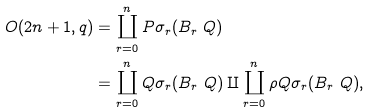Convert formula to latex. <formula><loc_0><loc_0><loc_500><loc_500>O ( 2 n + 1 , q ) & = \coprod _ { r = 0 } ^ { n } P \sigma _ { r } ( B _ { r } \ Q ) \\ & = \coprod _ { r = 0 } ^ { n } Q \sigma _ { r } ( B _ { r } \ Q ) \amalg \coprod _ { r = 0 } ^ { n } \rho Q \sigma _ { r } ( B _ { r } \ Q ) ,</formula> 